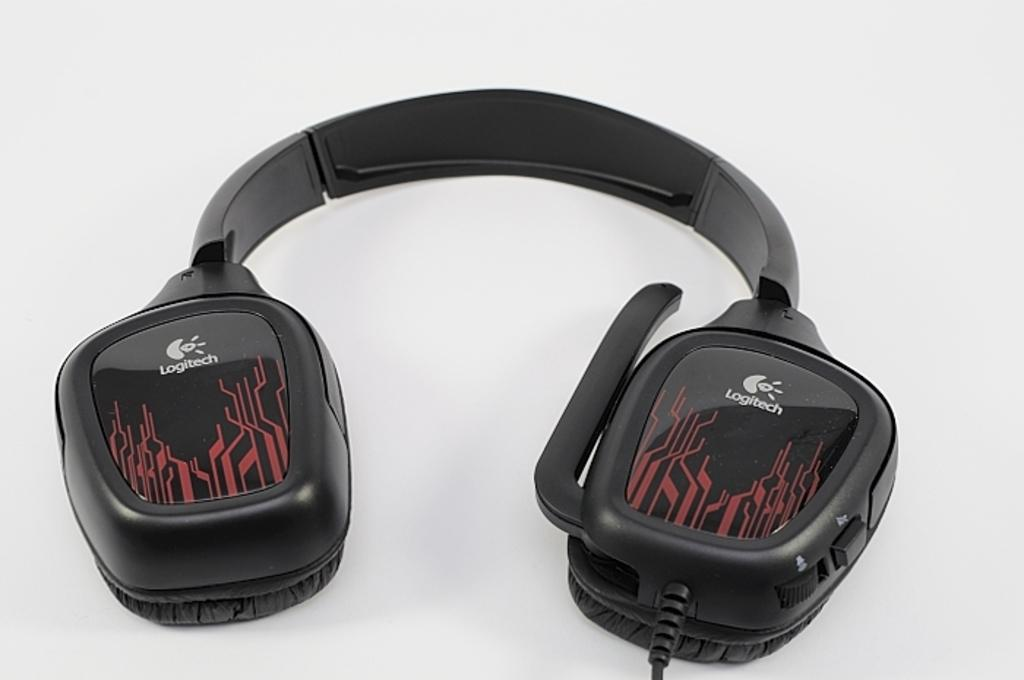<image>
Relay a brief, clear account of the picture shown. A pair of black and red Logitech headphones. 